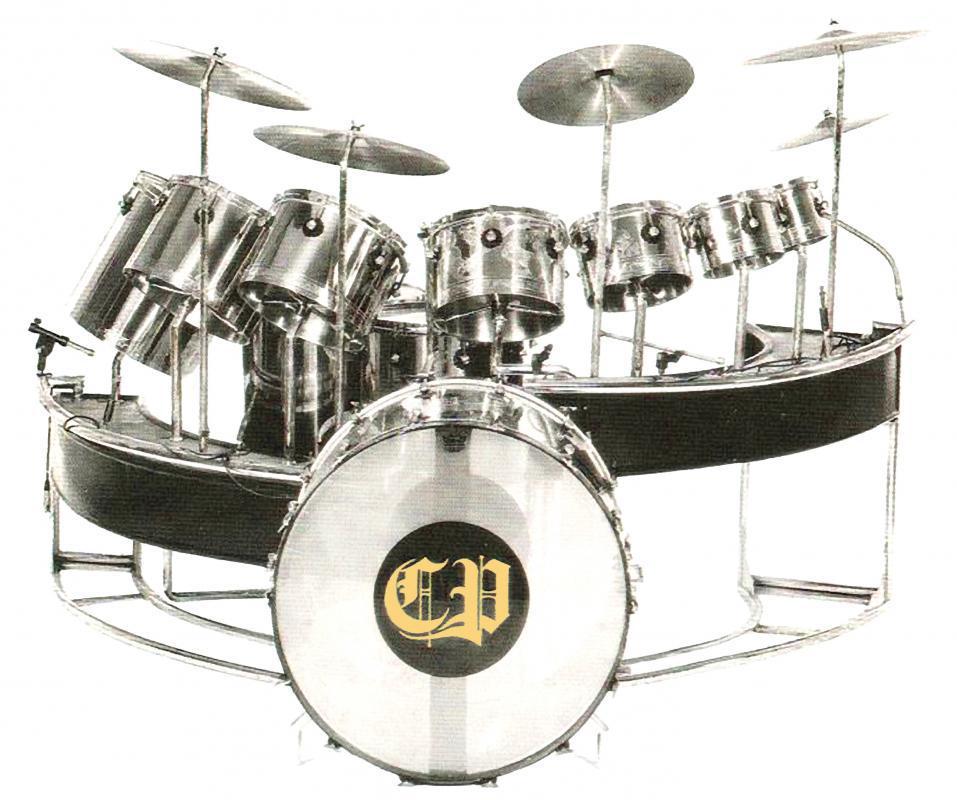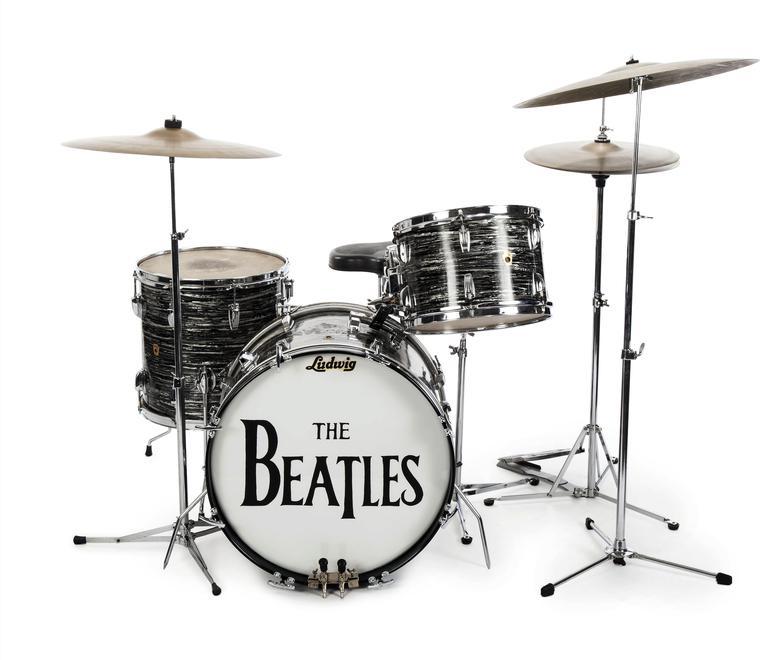The first image is the image on the left, the second image is the image on the right. Evaluate the accuracy of this statement regarding the images: "There is a man in one image, but not the other.". Is it true? Answer yes or no. No. 